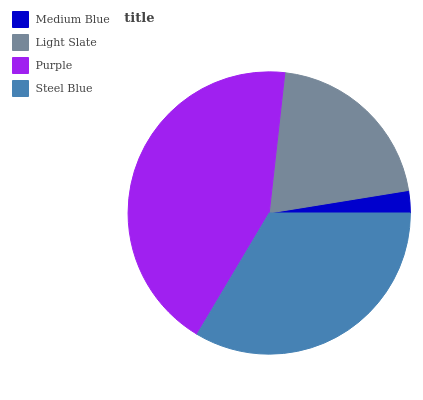Is Medium Blue the minimum?
Answer yes or no. Yes. Is Purple the maximum?
Answer yes or no. Yes. Is Light Slate the minimum?
Answer yes or no. No. Is Light Slate the maximum?
Answer yes or no. No. Is Light Slate greater than Medium Blue?
Answer yes or no. Yes. Is Medium Blue less than Light Slate?
Answer yes or no. Yes. Is Medium Blue greater than Light Slate?
Answer yes or no. No. Is Light Slate less than Medium Blue?
Answer yes or no. No. Is Steel Blue the high median?
Answer yes or no. Yes. Is Light Slate the low median?
Answer yes or no. Yes. Is Purple the high median?
Answer yes or no. No. Is Steel Blue the low median?
Answer yes or no. No. 